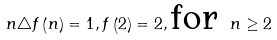Convert formula to latex. <formula><loc_0><loc_0><loc_500><loc_500>n \triangle f \left ( n \right ) = 1 , f \left ( 2 \right ) = 2 , \text {for } n \geq 2</formula> 